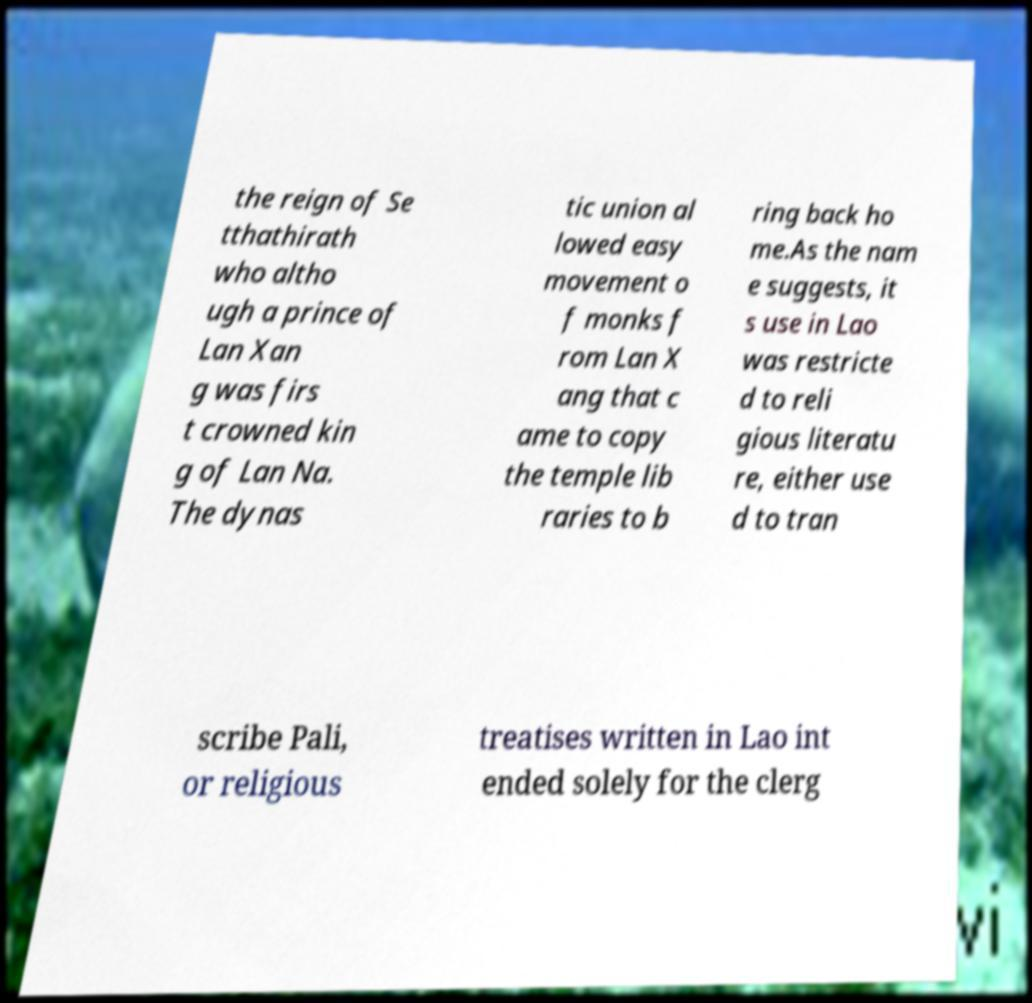There's text embedded in this image that I need extracted. Can you transcribe it verbatim? the reign of Se tthathirath who altho ugh a prince of Lan Xan g was firs t crowned kin g of Lan Na. The dynas tic union al lowed easy movement o f monks f rom Lan X ang that c ame to copy the temple lib raries to b ring back ho me.As the nam e suggests, it s use in Lao was restricte d to reli gious literatu re, either use d to tran scribe Pali, or religious treatises written in Lao int ended solely for the clerg 